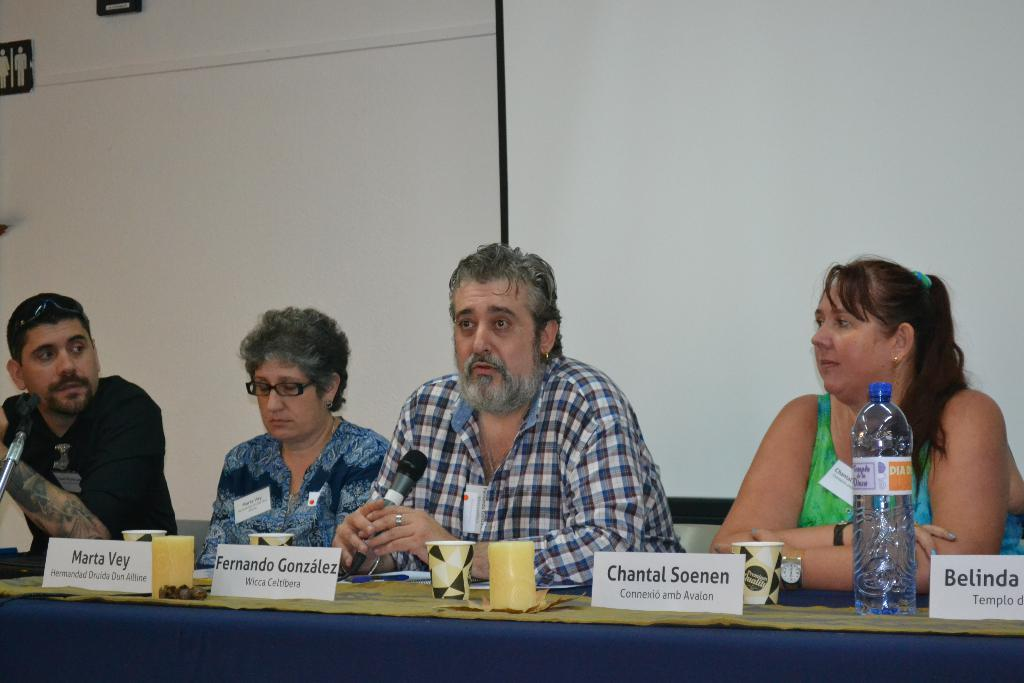How many people are in the image? There are 2 men and 2 women in the image. What are the people in the image doing? They are sitting in front of a table. What is on the table in the image? There are board games, a water bottle, and cups on the table. What can be seen in the background of the image? There is a wall and a banner in the background of the image. How many beds are visible in the image? There are no beds visible in the image. Can you describe the kettle on the table in the image? There is no kettle present on the table in the image. 